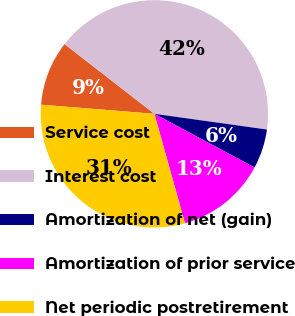Convert chart to OTSL. <chart><loc_0><loc_0><loc_500><loc_500><pie_chart><fcel>Service cost<fcel>Interest cost<fcel>Amortization of net (gain)<fcel>Amortization of prior service<fcel>Net periodic postretirement<nl><fcel>9.23%<fcel>41.7%<fcel>5.62%<fcel>12.83%<fcel>30.62%<nl></chart> 